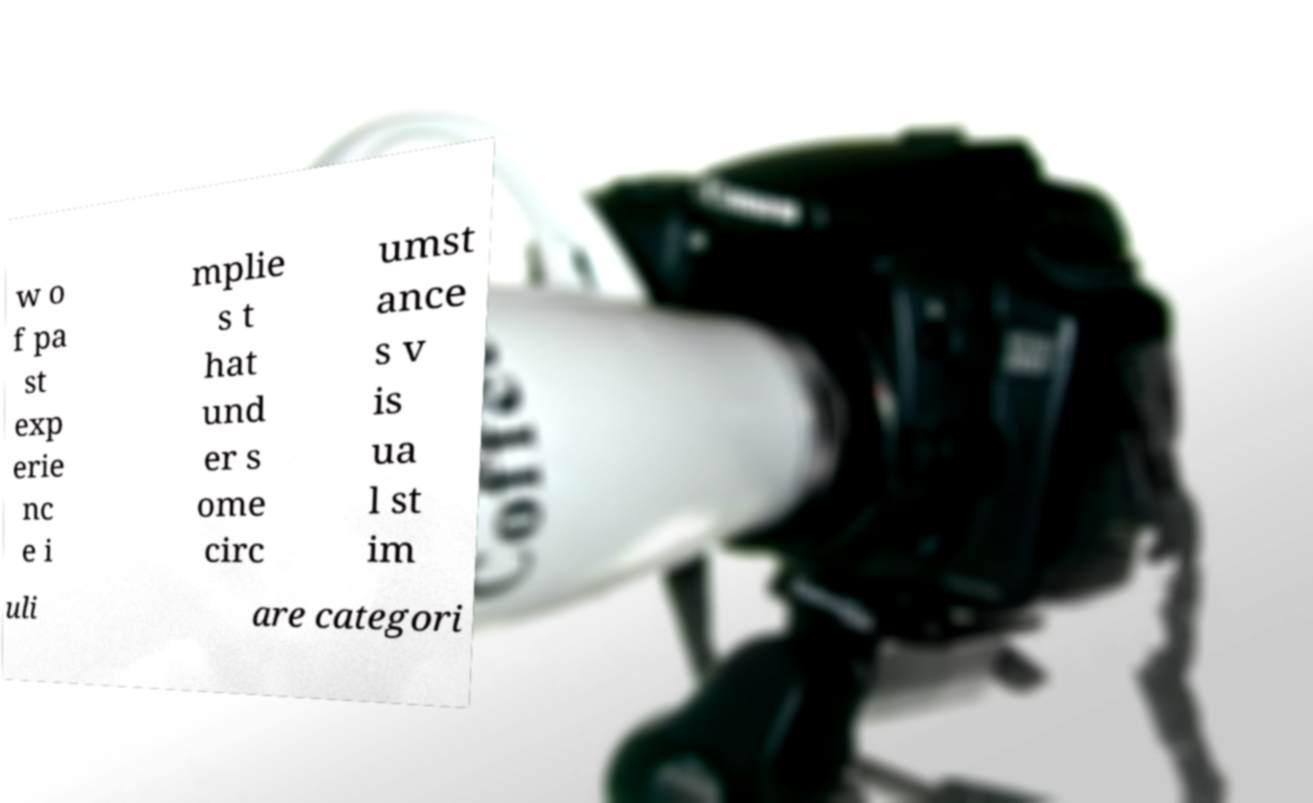Please read and relay the text visible in this image. What does it say? w o f pa st exp erie nc e i mplie s t hat und er s ome circ umst ance s v is ua l st im uli are categori 